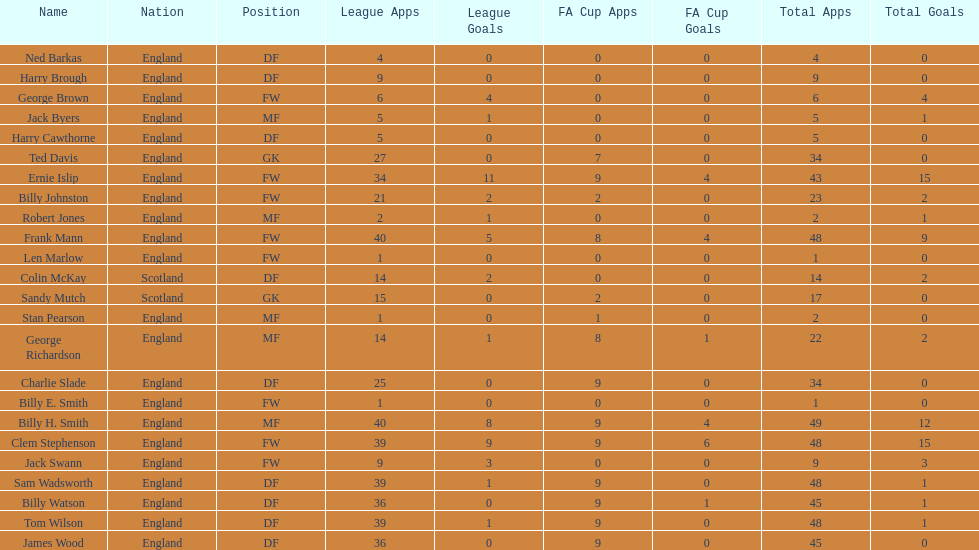Can you identify the first name listed? Ned Barkas. 